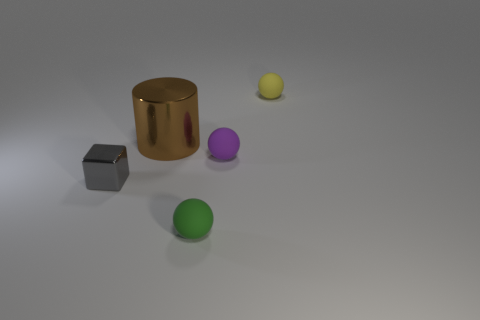How many yellow rubber spheres have the same size as the metallic cube?
Provide a short and direct response. 1. Are there fewer purple matte balls left of the small metallic cube than objects in front of the brown metallic cylinder?
Give a very brief answer. Yes. How big is the object that is in front of the tiny thing that is on the left side of the matte object that is to the left of the tiny purple rubber sphere?
Provide a succinct answer. Small. There is a object that is behind the small purple rubber object and in front of the tiny yellow object; what size is it?
Offer a very short reply. Large. What is the shape of the tiny object on the left side of the tiny rubber ball that is in front of the tiny shiny object?
Offer a very short reply. Cube. The thing left of the large metallic thing has what shape?
Give a very brief answer. Cube. The thing that is on the left side of the purple rubber sphere and to the right of the brown metallic cylinder has what shape?
Your answer should be very brief. Sphere. What size is the metallic object that is on the right side of the tiny thing that is left of the brown cylinder?
Give a very brief answer. Large. What is the material of the gray thing that is the same size as the yellow rubber sphere?
Provide a short and direct response. Metal. How many cubes are tiny gray objects or green matte objects?
Provide a succinct answer. 1. 